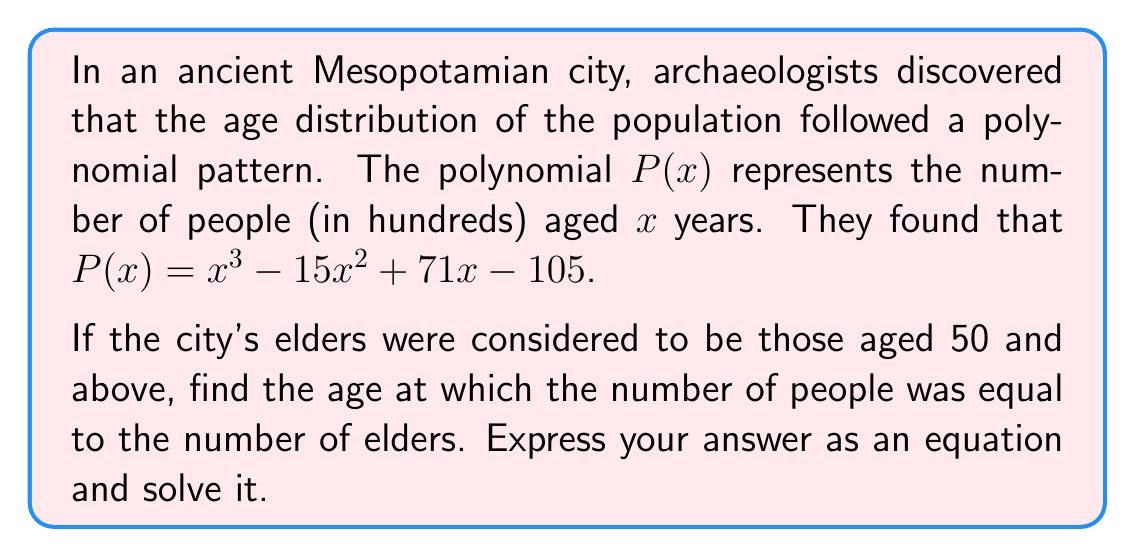Help me with this question. Let's approach this step-by-step:

1) First, we need to find the number of elders. This is the value of $P(50)$:

   $P(50) = 50^3 - 15(50^2) + 71(50) - 105$
   $= 125000 - 37500 + 3550 - 105$
   $= 90945$

   So there are 90,945 elders (remember, $P(x)$ is in hundreds).

2) Now, we need to find the age $x$ where $P(x) = 90945$. This gives us the equation:

   $x^3 - 15x^2 + 71x - 105 = 90945$

3) To solve this, let's subtract 90945 from both sides:

   $x^3 - 15x^2 + 71x - 91050 = 0$

4) This is a cubic equation. One way to solve it is to guess one solution and then use polynomial long division. Given the context, let's try $x = 50$:

   $50^3 - 15(50^2) + 71(50) - 91050 = 125000 - 37500 + 3550 - 91050 = 0$

5) Indeed, 50 is a solution. So $(x - 50)$ is a factor. Let's divide the polynomial by $(x - 50)$:

   $x^3 - 15x^2 + 71x - 91050 = (x - 50)(x^2 + 35x - 1821)$

6) Now we have a quadratic equation to solve: $x^2 + 35x - 1821 = 0$

7) We can solve this using the quadratic formula: $x = \frac{-b \pm \sqrt{b^2 - 4ac}}{2a}$

   Here, $a = 1$, $b = 35$, and $c = -1821$

   $x = \frac{-35 \pm \sqrt{35^2 - 4(1)(-1821)}}{2(1)}$
   $= \frac{-35 \pm \sqrt{1225 + 7284}}{2}$
   $= \frac{-35 \pm \sqrt{8509}}{2}$

8) This gives us two more solutions:

   $x = \frac{-35 + 92.24}{2} \approx 28.62$ and $x = \frac{-35 - 92.24}{2} \approx -63.62$

9) The negative solution doesn't make sense in this context, so we can discard it.

Therefore, the two relevant solutions are $x = 50$ and $x \approx 28.62$.
Answer: The ages at which the number of people was equal to the number of elders are 50 years and approximately 28.62 years. 